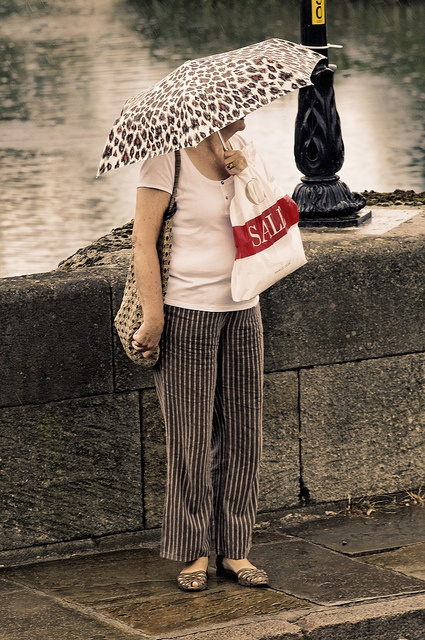Describe the objects in this image and their specific colors. I can see people in gray, black, and tan tones, umbrella in gray, ivory, and tan tones, handbag in gray, lightgray, brown, and tan tones, and handbag in gray, black, and tan tones in this image. 